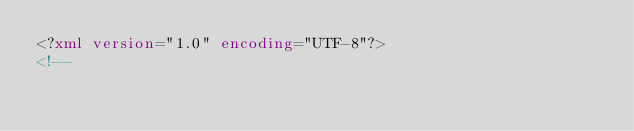<code> <loc_0><loc_0><loc_500><loc_500><_XML_><?xml version="1.0" encoding="UTF-8"?>
<!--
</code> 